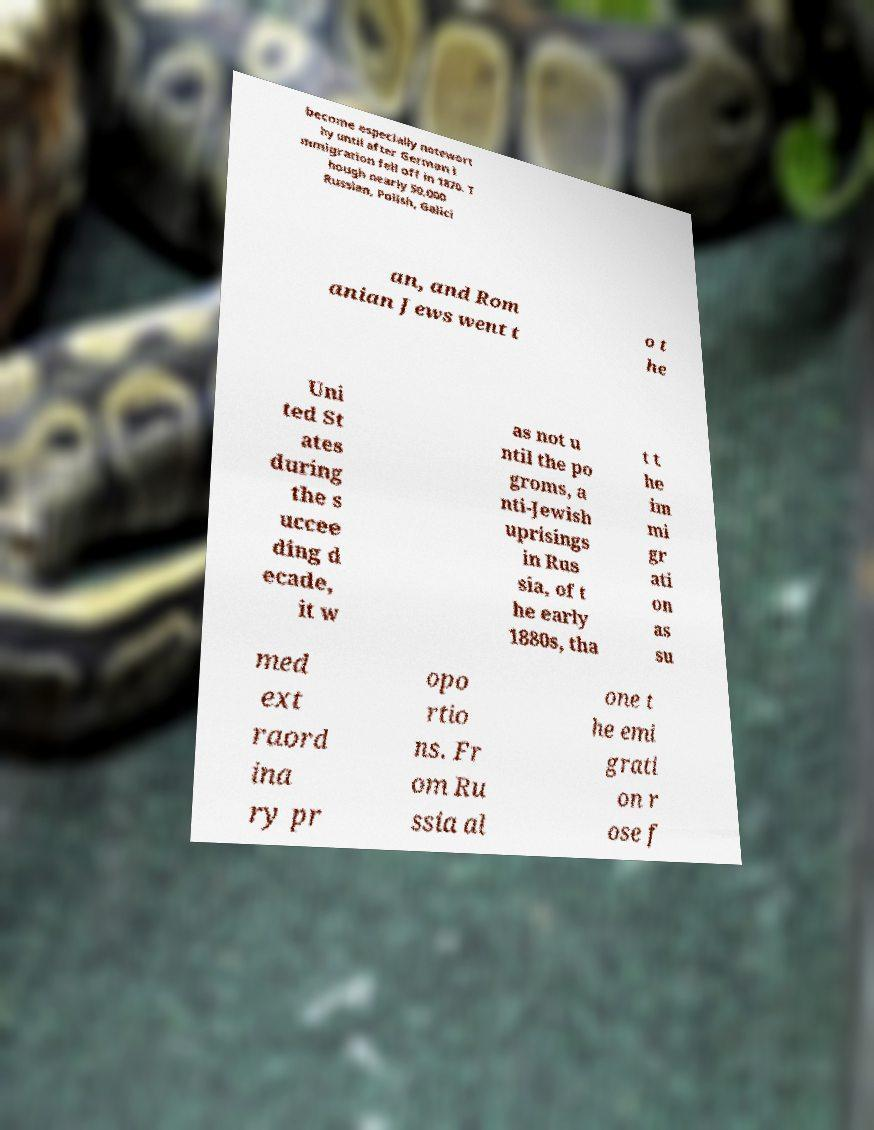Can you accurately transcribe the text from the provided image for me? become especially notewort hy until after German i mmigration fell off in 1870. T hough nearly 50,000 Russian, Polish, Galici an, and Rom anian Jews went t o t he Uni ted St ates during the s uccee ding d ecade, it w as not u ntil the po groms, a nti-Jewish uprisings in Rus sia, of t he early 1880s, tha t t he im mi gr ati on as su med ext raord ina ry pr opo rtio ns. Fr om Ru ssia al one t he emi grati on r ose f 